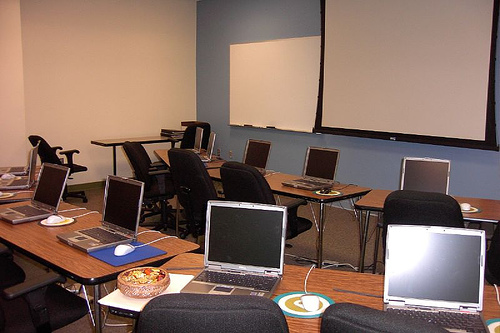How many laptops are there? Upon closer inspection of the image, it appears there are a total of 5 laptops visible on the desks within this conference room, not 10 as previously stated. 